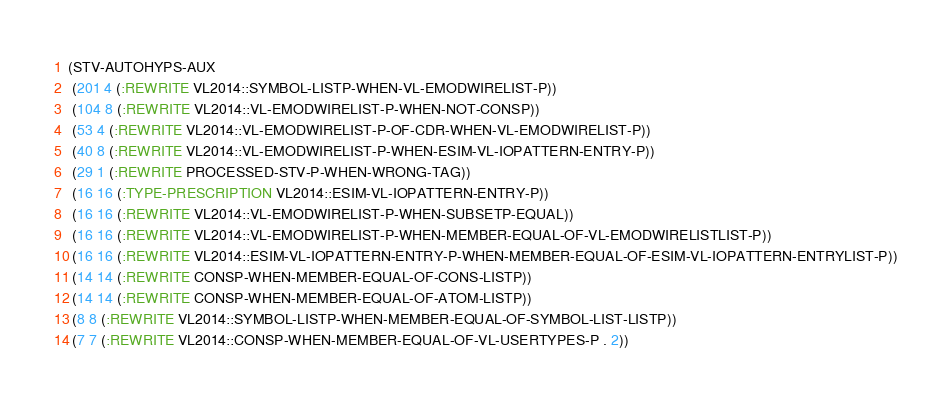<code> <loc_0><loc_0><loc_500><loc_500><_Lisp_>(STV-AUTOHYPS-AUX
 (201 4 (:REWRITE VL2014::SYMBOL-LISTP-WHEN-VL-EMODWIRELIST-P))
 (104 8 (:REWRITE VL2014::VL-EMODWIRELIST-P-WHEN-NOT-CONSP))
 (53 4 (:REWRITE VL2014::VL-EMODWIRELIST-P-OF-CDR-WHEN-VL-EMODWIRELIST-P))
 (40 8 (:REWRITE VL2014::VL-EMODWIRELIST-P-WHEN-ESIM-VL-IOPATTERN-ENTRY-P))
 (29 1 (:REWRITE PROCESSED-STV-P-WHEN-WRONG-TAG))
 (16 16 (:TYPE-PRESCRIPTION VL2014::ESIM-VL-IOPATTERN-ENTRY-P))
 (16 16 (:REWRITE VL2014::VL-EMODWIRELIST-P-WHEN-SUBSETP-EQUAL))
 (16 16 (:REWRITE VL2014::VL-EMODWIRELIST-P-WHEN-MEMBER-EQUAL-OF-VL-EMODWIRELISTLIST-P))
 (16 16 (:REWRITE VL2014::ESIM-VL-IOPATTERN-ENTRY-P-WHEN-MEMBER-EQUAL-OF-ESIM-VL-IOPATTERN-ENTRYLIST-P))
 (14 14 (:REWRITE CONSP-WHEN-MEMBER-EQUAL-OF-CONS-LISTP))
 (14 14 (:REWRITE CONSP-WHEN-MEMBER-EQUAL-OF-ATOM-LISTP))
 (8 8 (:REWRITE VL2014::SYMBOL-LISTP-WHEN-MEMBER-EQUAL-OF-SYMBOL-LIST-LISTP))
 (7 7 (:REWRITE VL2014::CONSP-WHEN-MEMBER-EQUAL-OF-VL-USERTYPES-P . 2))</code> 